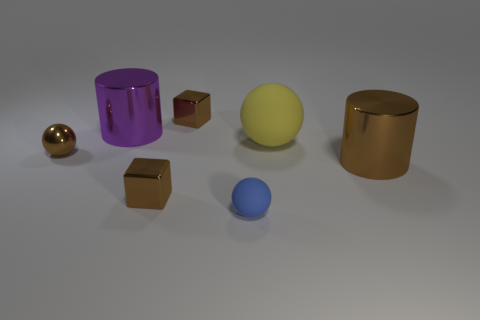How does the lighting affect the appearance of these objects? The lighting creates soft shadows and highlights that enhance the objects' three-dimensionality. The reflective surfaces of the cylindrical objects and the smaller sphere catch the light strongly, creating bright areas and defined reflections that give a sense of the texture and curvature of the objects. Could you estimate the time of day depicted by the lighting? Since this appears to be a studio setup without natural lighting cues, it is not possible to estimate a time of day. The lighting is artificial and designed to create a neutral environment to display the objects without the influence of direct sunlight or a specific time-related ambiance. 